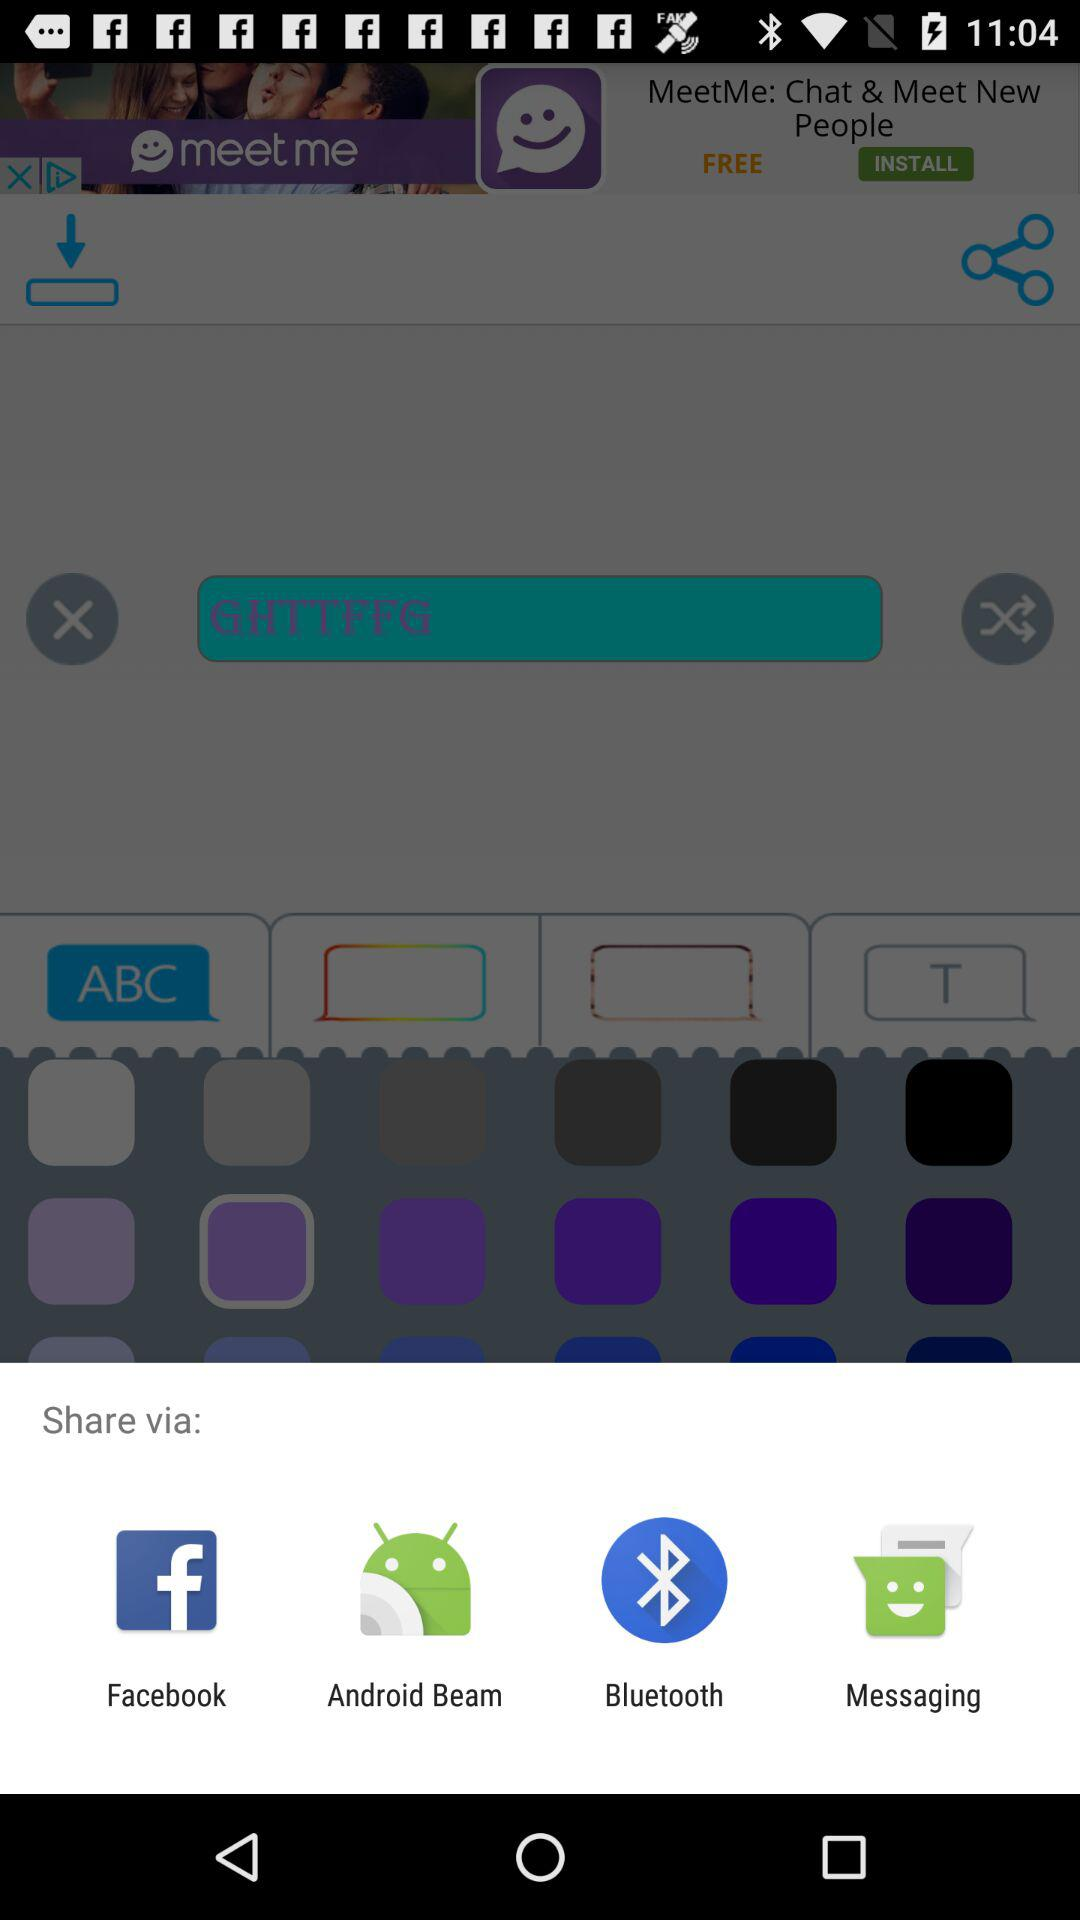What applications can be used to share? The applications that can be used to share are "Facebook", "Android Beam", "Bluetooth" and "Messaging". 